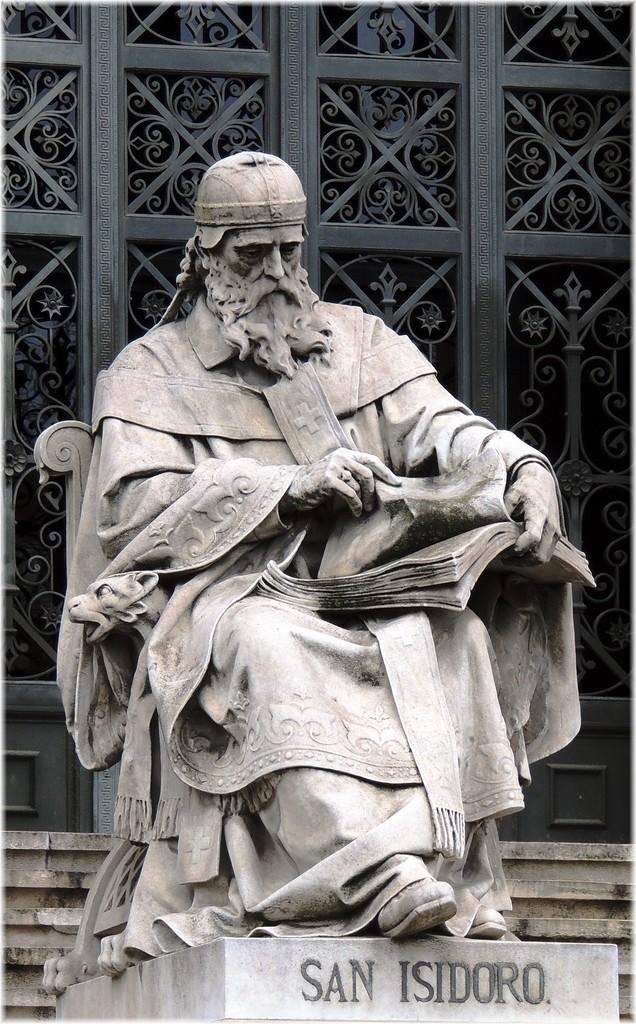What is the main subject in the center of the image? There is a statue in the center of the image. What can be seen in the background of the image? There is a gate in the background of the image. How does the statue remain quiet in the image? The statue is an inanimate object and does not make any noise, so it does not need to remain quiet. 